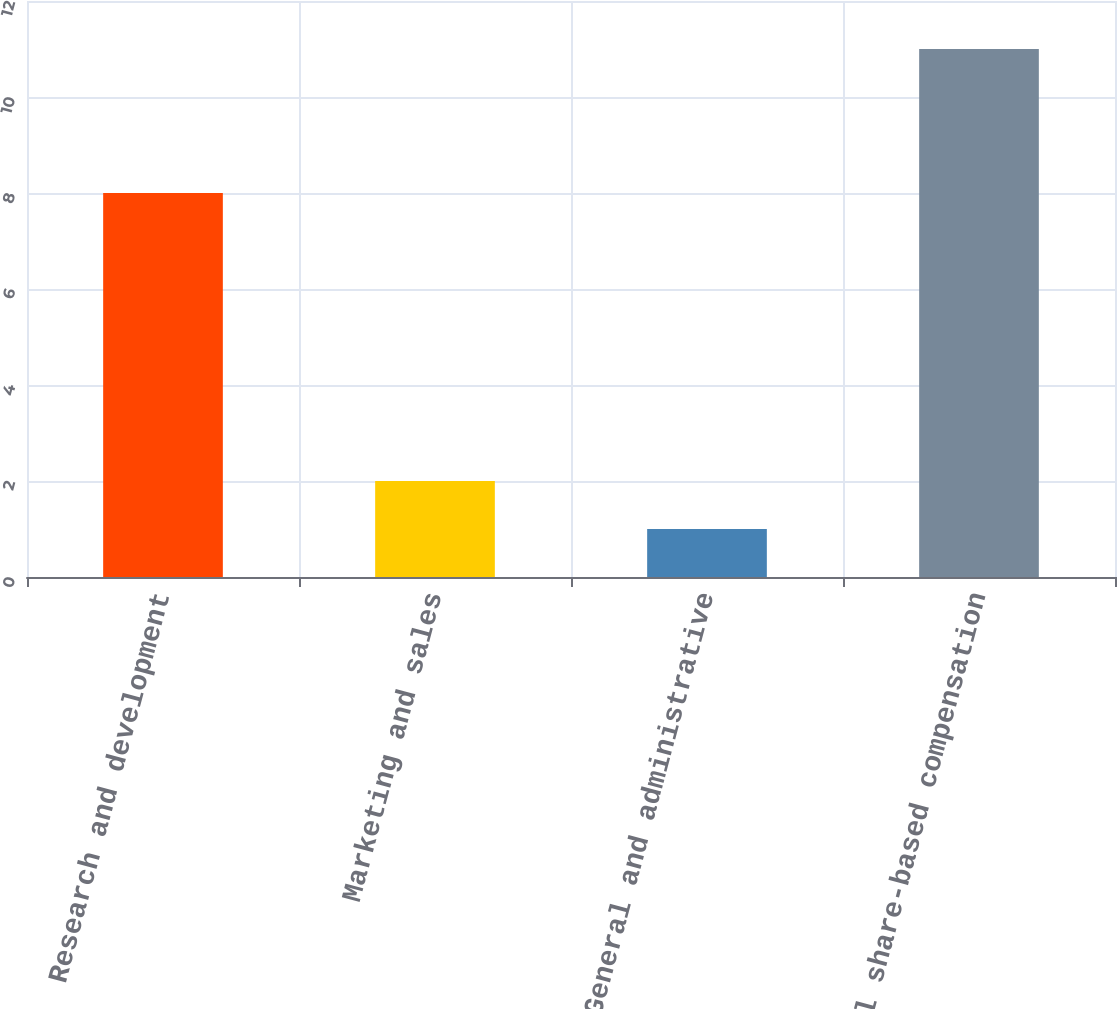Convert chart to OTSL. <chart><loc_0><loc_0><loc_500><loc_500><bar_chart><fcel>Research and development<fcel>Marketing and sales<fcel>General and administrative<fcel>Total share-based compensation<nl><fcel>8<fcel>2<fcel>1<fcel>11<nl></chart> 